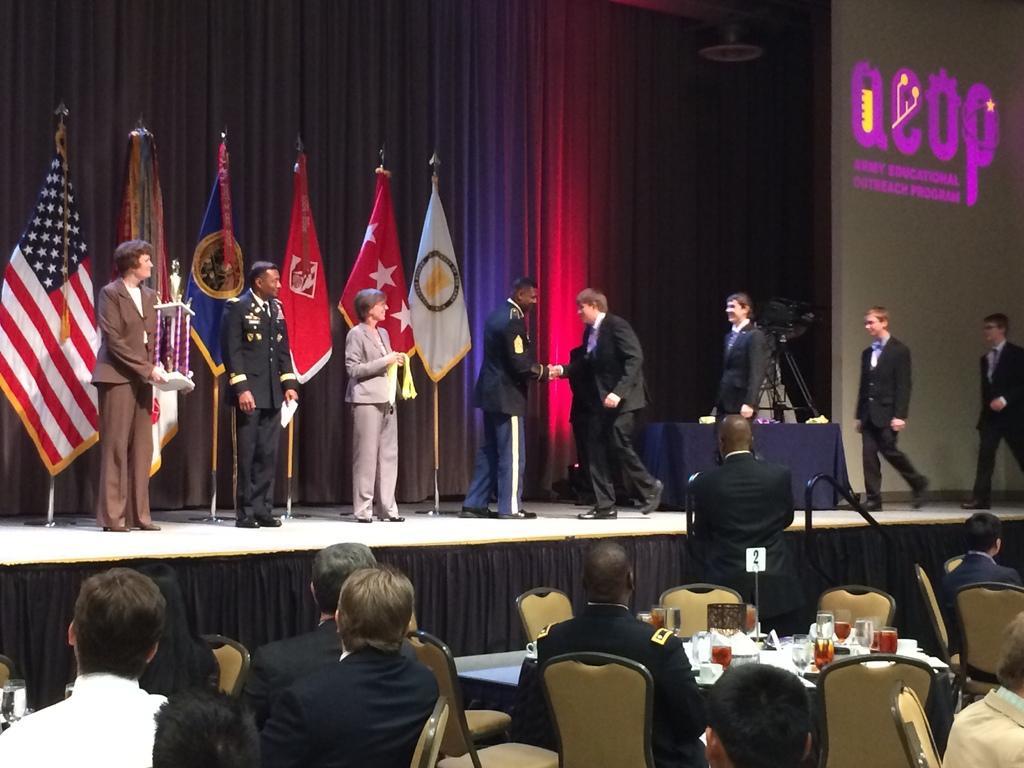How would you summarize this image in a sentence or two? In this image I see number of people in which few of them are on the stage and I see rest of them over here and few of them are sitting on chairs and I see a man over here and on the stage I see number of flags over here and I see few words written over here and I see the curtains and I see glasses and other things on this table. 